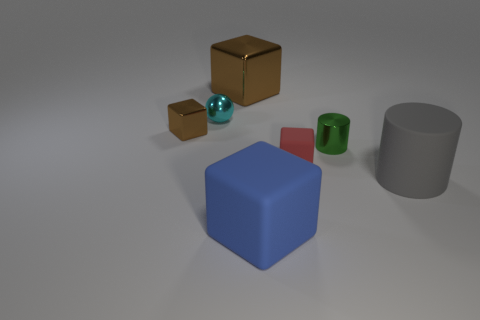Subtract all red cubes. How many cubes are left? 3 Subtract all blue matte cubes. How many cubes are left? 3 Subtract all purple cubes. Subtract all purple balls. How many cubes are left? 4 Add 1 tiny cubes. How many objects exist? 8 Subtract all cylinders. How many objects are left? 5 Subtract all big brown cubes. Subtract all tiny metallic cylinders. How many objects are left? 5 Add 5 rubber things. How many rubber things are left? 8 Add 3 small purple things. How many small purple things exist? 3 Subtract 0 gray spheres. How many objects are left? 7 